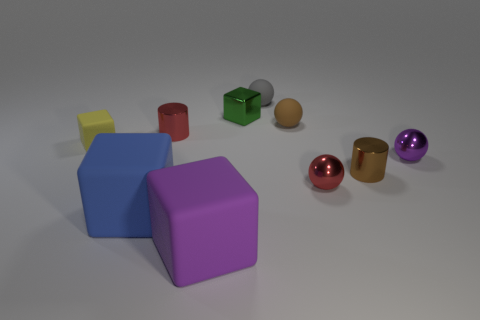What might be the function of these objects in real life? These objects resemble simple geometrical shapes and could serve as educational aids for teaching shapes and colors, toys for children to play with, or as decorative elements. In another context, they might be prototypes for product design or elements in a virtual reality environment. 